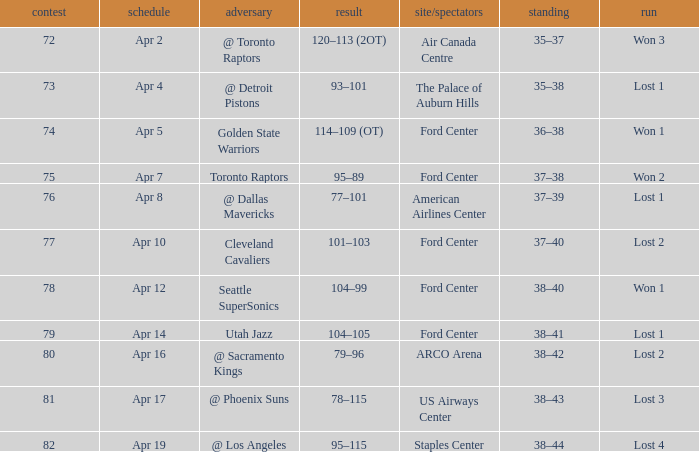What was the record for less than 78 games and a score of 114–109 (ot)? 36–38. 